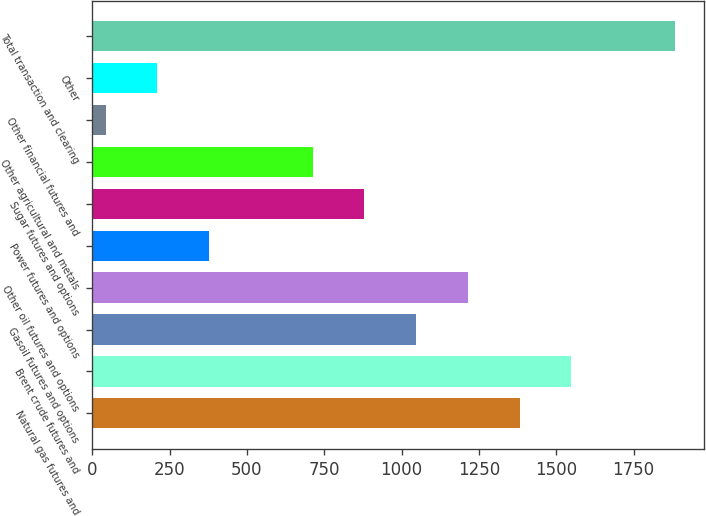Convert chart to OTSL. <chart><loc_0><loc_0><loc_500><loc_500><bar_chart><fcel>Natural gas futures and<fcel>Brent crude futures and<fcel>Gasoil futures and options<fcel>Other oil futures and options<fcel>Power futures and options<fcel>Sugar futures and options<fcel>Other agricultural and metals<fcel>Other financial futures and<fcel>Other<fcel>Total transaction and clearing<nl><fcel>1381.4<fcel>1548.7<fcel>1046.8<fcel>1214.1<fcel>377.6<fcel>879.5<fcel>712.2<fcel>43<fcel>210.3<fcel>1883.3<nl></chart> 